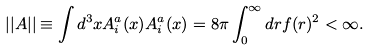Convert formula to latex. <formula><loc_0><loc_0><loc_500><loc_500>| | A | | \equiv \int d ^ { 3 } x A ^ { a } _ { i } ( x ) A ^ { a } _ { i } ( x ) = 8 \pi \int _ { 0 } ^ { \infty } d r f ( r ) ^ { 2 } < \infty .</formula> 